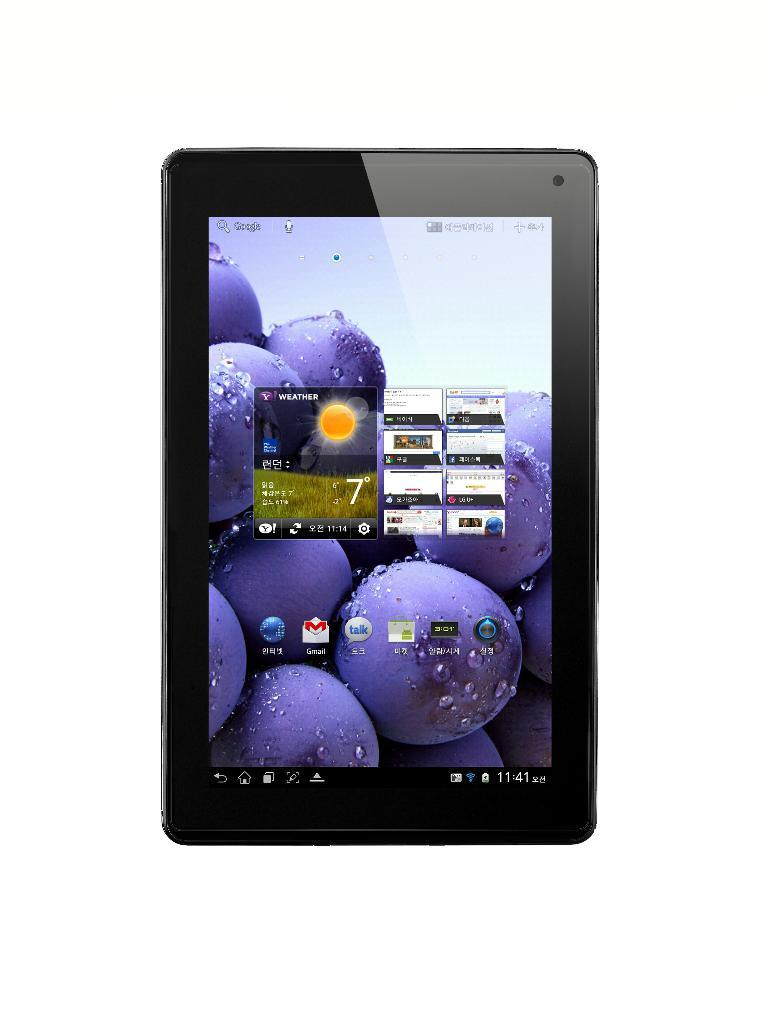What is the main subject of the image? The main subject of the image is a tab. What can be found on the tab? The tab contains text and images. How does the tab cause trouble for the fly in the image? There is no fly present in the image, and the tab does not cause any trouble. 